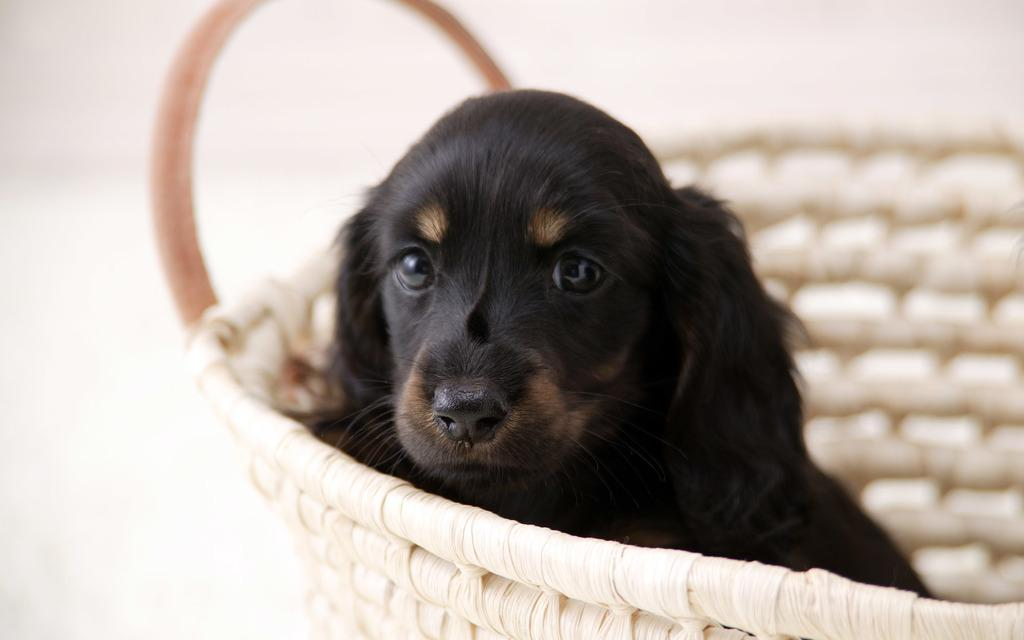What animal is present in the image? There is a dog in the image. Where is the dog located in the image? The dog is in a basket. What type of veil is draped over the dog in the image? There is no veil present in the image; the dog is in a basket. What type of ship can be seen sailing in the background of the image? There is no ship present in the image; it only features a dog in a basket. 